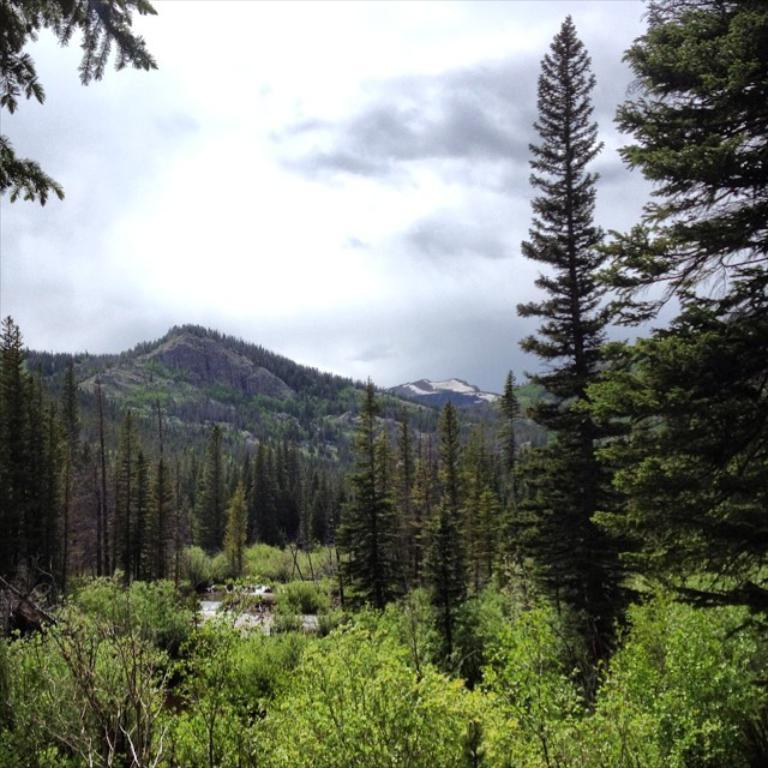What type of vegetation can be seen in the image? There are trees in the image. What natural feature is visible in the background of the image? There are mountains in the background of the image. What type of toothpaste is being used to clean the trees in the image? There is no toothpaste present in the image, and trees are not cleaned with toothpaste. 